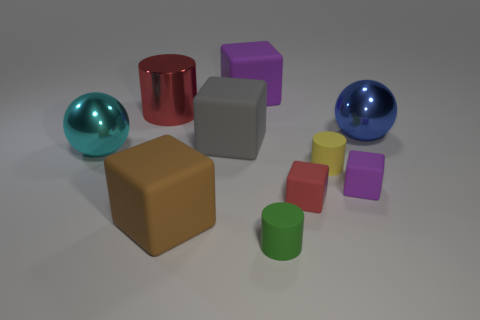Subtract all tiny cylinders. How many cylinders are left? 1 Subtract all blue spheres. How many purple blocks are left? 2 Subtract 1 cylinders. How many cylinders are left? 2 Subtract all red blocks. How many blocks are left? 4 Subtract all yellow blocks. Subtract all green cylinders. How many blocks are left? 5 Subtract all blue things. Subtract all small purple blocks. How many objects are left? 8 Add 8 blue spheres. How many blue spheres are left? 9 Add 3 small purple blocks. How many small purple blocks exist? 4 Subtract 1 cyan spheres. How many objects are left? 9 Subtract all spheres. How many objects are left? 8 